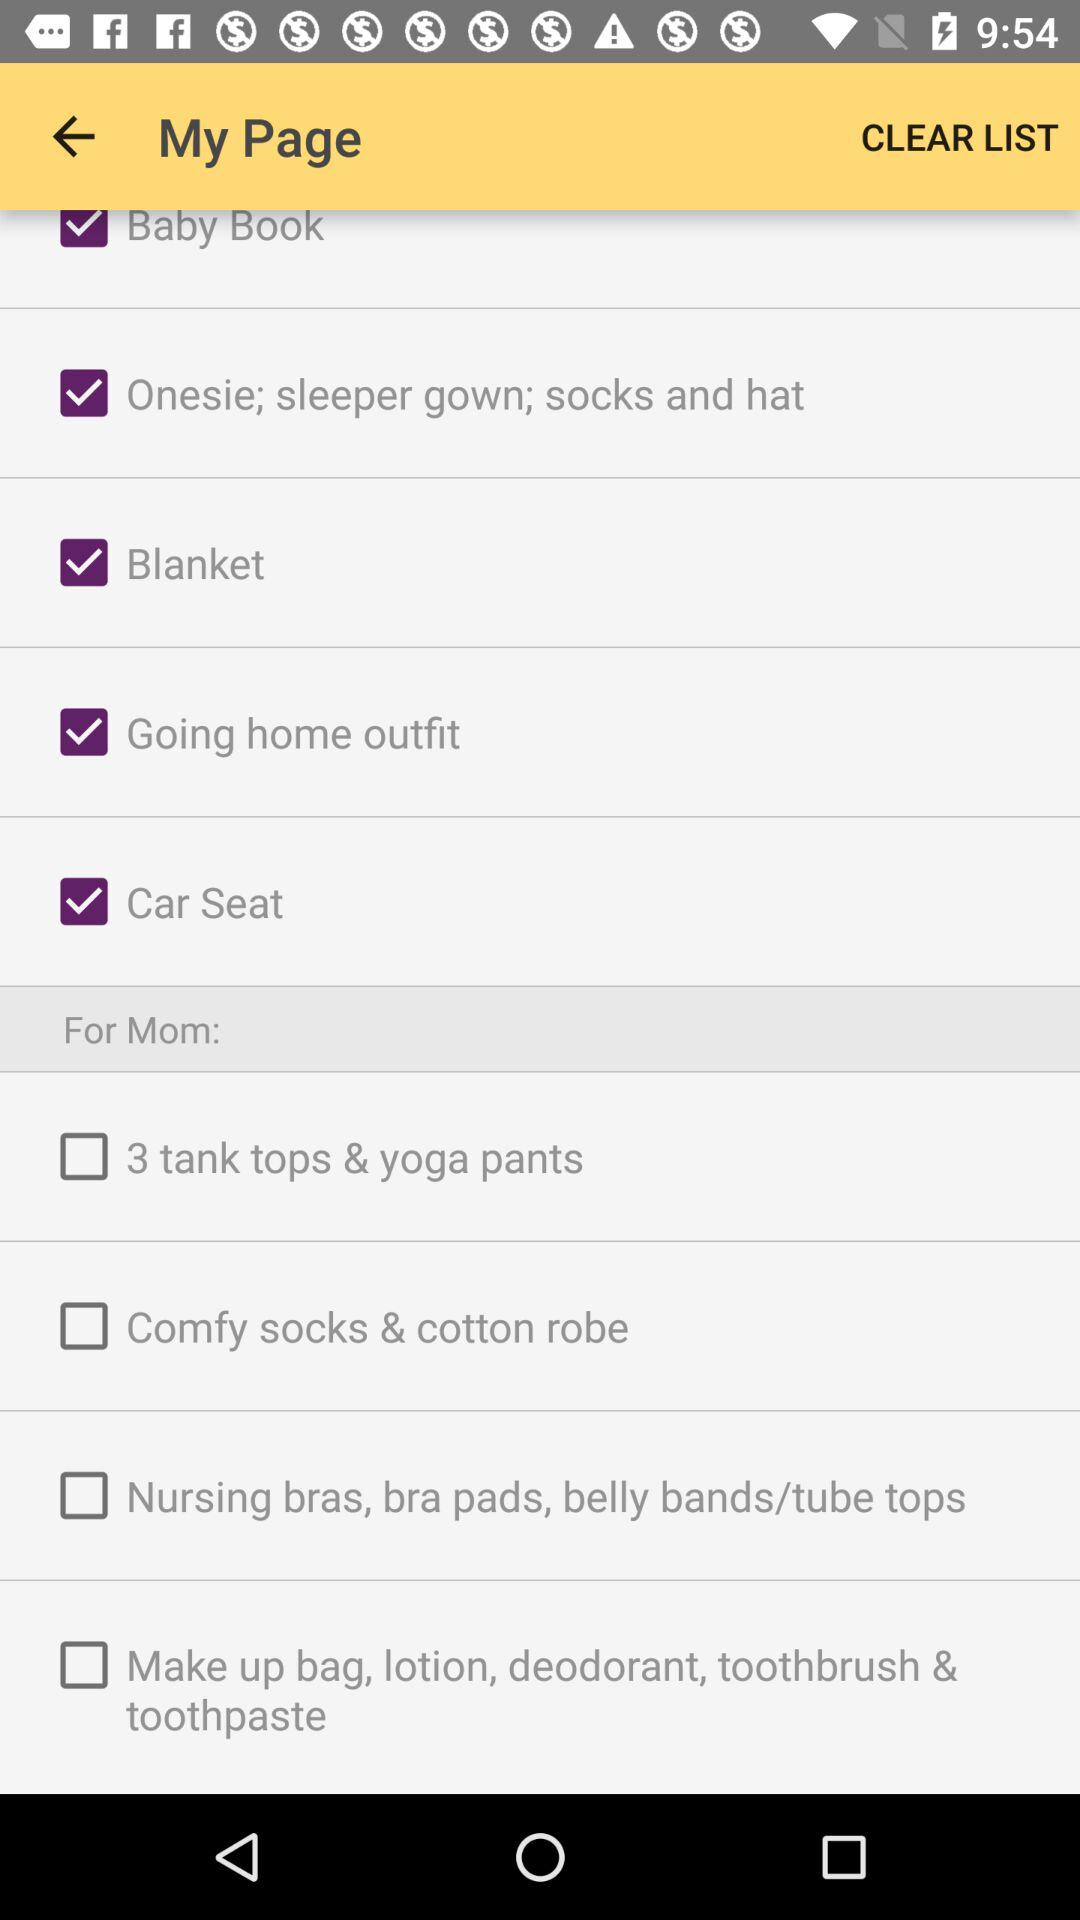What is the status of "Blanket"? The status of "Blanket" is "on". 